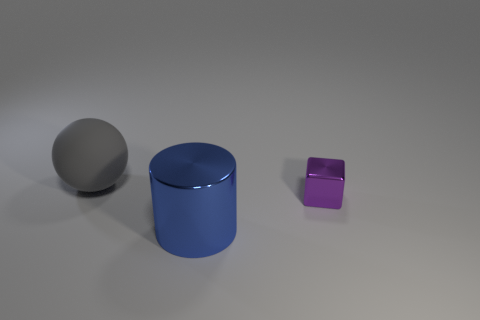Are there any gray things?
Your response must be concise. Yes. There is a shiny thing behind the blue thing that is on the left side of the tiny thing; what size is it?
Provide a succinct answer. Small. Are there more big matte spheres in front of the large gray matte ball than big metal things that are behind the tiny metal object?
Your answer should be very brief. No. How many balls are small yellow shiny things or big gray things?
Offer a terse response. 1. Is there any other thing that has the same size as the blue thing?
Make the answer very short. Yes. There is a big object that is behind the blue metal cylinder; is it the same shape as the tiny shiny thing?
Provide a succinct answer. No. What is the color of the matte object?
Your response must be concise. Gray. What number of other small metal things have the same shape as the tiny purple metal object?
Your answer should be compact. 0. How many things are large purple shiny blocks or things in front of the large ball?
Your answer should be very brief. 2. What is the size of the object that is to the left of the purple block and to the right of the gray matte ball?
Offer a very short reply. Large. 